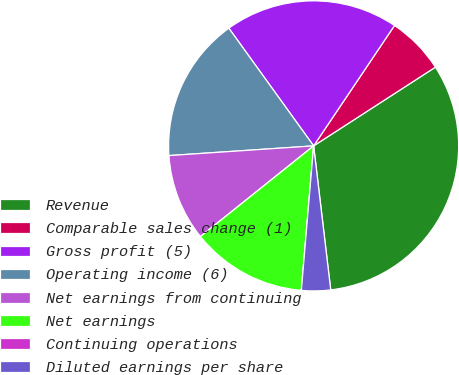Convert chart. <chart><loc_0><loc_0><loc_500><loc_500><pie_chart><fcel>Revenue<fcel>Comparable sales change (1)<fcel>Gross profit (5)<fcel>Operating income (6)<fcel>Net earnings from continuing<fcel>Net earnings<fcel>Continuing operations<fcel>Diluted earnings per share<nl><fcel>32.25%<fcel>6.45%<fcel>19.35%<fcel>16.13%<fcel>9.68%<fcel>12.9%<fcel>0.0%<fcel>3.23%<nl></chart> 